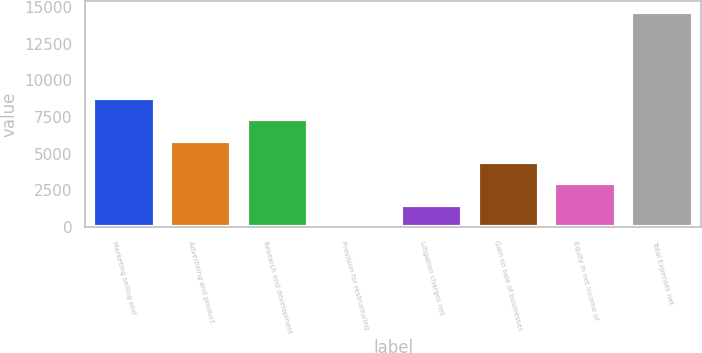Convert chart to OTSL. <chart><loc_0><loc_0><loc_500><loc_500><bar_chart><fcel>Marketing selling and<fcel>Advertising and product<fcel>Research and development<fcel>Provision for restructuring<fcel>Litigation charges net<fcel>Gain on sale of businesses<fcel>Equity in net income of<fcel>Total Expenses net<nl><fcel>8827.4<fcel>5895.6<fcel>7361.5<fcel>32<fcel>1497.9<fcel>4429.7<fcel>2963.8<fcel>14691<nl></chart> 